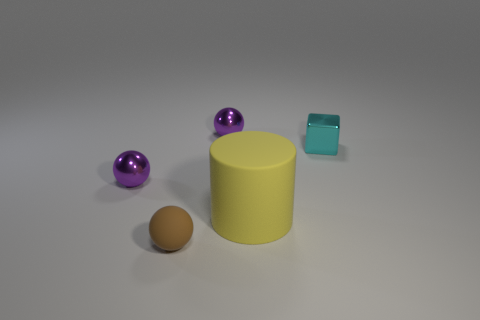How many purple spheres must be subtracted to get 1 purple spheres? 1 Add 1 cyan metallic objects. How many objects exist? 6 Subtract all blocks. How many objects are left? 4 Add 5 small metallic cubes. How many small metallic cubes are left? 6 Add 4 green matte blocks. How many green matte blocks exist? 4 Subtract 0 red balls. How many objects are left? 5 Subtract all brown things. Subtract all spheres. How many objects are left? 1 